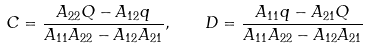Convert formula to latex. <formula><loc_0><loc_0><loc_500><loc_500>C = \frac { A _ { 2 2 } Q - A _ { 1 2 } q } { A _ { 1 1 } A _ { 2 2 } - A _ { 1 2 } A _ { 2 1 } } , \quad D = \frac { A _ { 1 1 } q - A _ { 2 1 } Q } { A _ { 1 1 } A _ { 2 2 } - A _ { 1 2 } A _ { 2 1 } }</formula> 